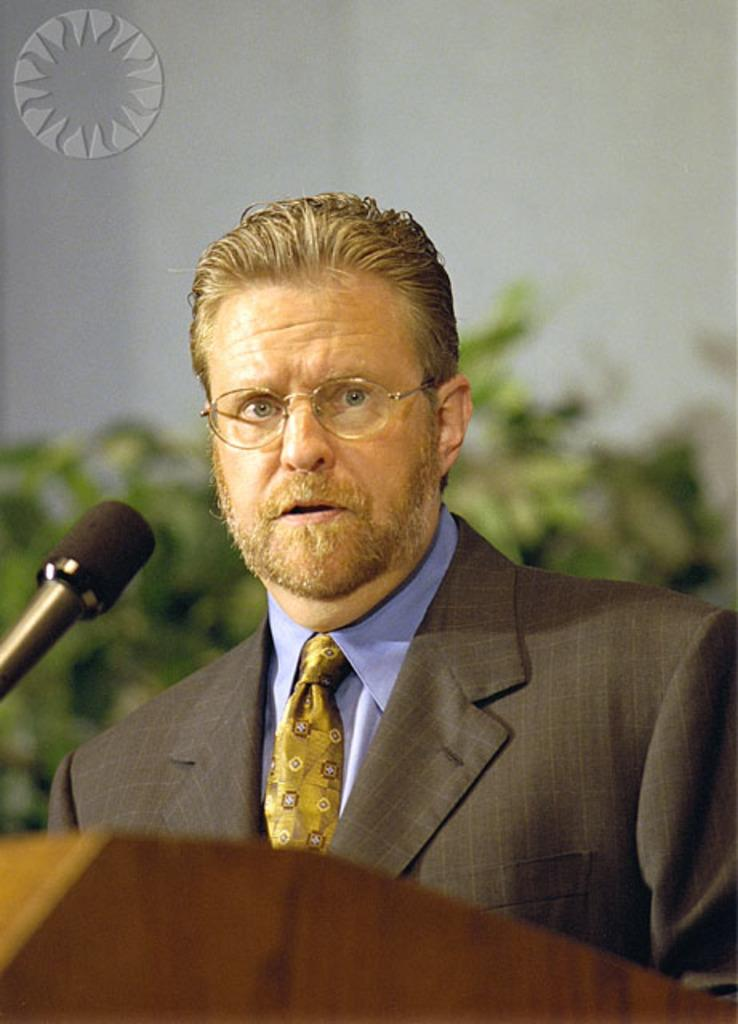Who or what is present in the image? There is a person in the image. What object is associated with the person in the image? There is a microphone (mic) in the image. What is the person standing near in the image? There is a podium in the image. What can be seen in the background of the image? There are plants visible in the background of the image. What type of lettuce is being used as a prop by the person in the image? There is no lettuce present in the image; it features a person with a microphone and a podium in front of plants. 